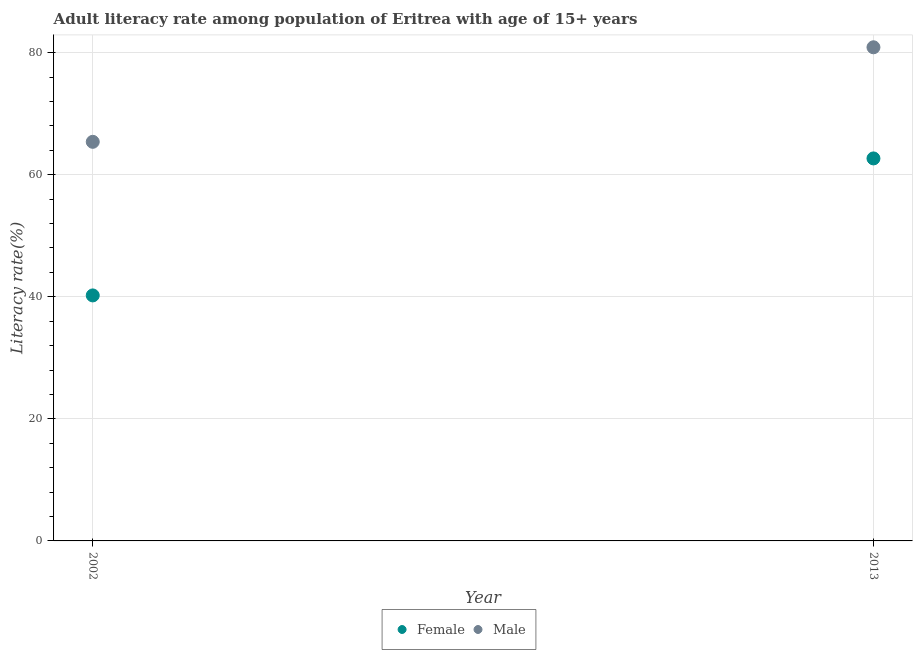How many different coloured dotlines are there?
Your answer should be very brief. 2. Is the number of dotlines equal to the number of legend labels?
Keep it short and to the point. Yes. What is the female adult literacy rate in 2013?
Give a very brief answer. 62.67. Across all years, what is the maximum male adult literacy rate?
Your response must be concise. 80.88. Across all years, what is the minimum female adult literacy rate?
Keep it short and to the point. 40.22. In which year was the male adult literacy rate maximum?
Provide a succinct answer. 2013. What is the total female adult literacy rate in the graph?
Your answer should be compact. 102.9. What is the difference between the female adult literacy rate in 2002 and that in 2013?
Offer a terse response. -22.45. What is the difference between the female adult literacy rate in 2013 and the male adult literacy rate in 2002?
Give a very brief answer. -2.72. What is the average male adult literacy rate per year?
Your answer should be very brief. 73.14. In the year 2002, what is the difference between the male adult literacy rate and female adult literacy rate?
Offer a terse response. 25.17. What is the ratio of the male adult literacy rate in 2002 to that in 2013?
Keep it short and to the point. 0.81. In how many years, is the female adult literacy rate greater than the average female adult literacy rate taken over all years?
Your answer should be compact. 1. Does the female adult literacy rate monotonically increase over the years?
Ensure brevity in your answer.  Yes. Is the female adult literacy rate strictly less than the male adult literacy rate over the years?
Your response must be concise. Yes. How many years are there in the graph?
Provide a short and direct response. 2. What is the difference between two consecutive major ticks on the Y-axis?
Ensure brevity in your answer.  20. Are the values on the major ticks of Y-axis written in scientific E-notation?
Ensure brevity in your answer.  No. Does the graph contain any zero values?
Ensure brevity in your answer.  No. Does the graph contain grids?
Ensure brevity in your answer.  Yes. Where does the legend appear in the graph?
Your answer should be very brief. Bottom center. What is the title of the graph?
Keep it short and to the point. Adult literacy rate among population of Eritrea with age of 15+ years. Does "Health Care" appear as one of the legend labels in the graph?
Your response must be concise. No. What is the label or title of the Y-axis?
Provide a succinct answer. Literacy rate(%). What is the Literacy rate(%) of Female in 2002?
Give a very brief answer. 40.22. What is the Literacy rate(%) of Male in 2002?
Your answer should be very brief. 65.39. What is the Literacy rate(%) in Female in 2013?
Provide a short and direct response. 62.67. What is the Literacy rate(%) of Male in 2013?
Provide a succinct answer. 80.88. Across all years, what is the maximum Literacy rate(%) in Female?
Offer a terse response. 62.67. Across all years, what is the maximum Literacy rate(%) of Male?
Keep it short and to the point. 80.88. Across all years, what is the minimum Literacy rate(%) of Female?
Keep it short and to the point. 40.22. Across all years, what is the minimum Literacy rate(%) in Male?
Offer a very short reply. 65.39. What is the total Literacy rate(%) in Female in the graph?
Make the answer very short. 102.9. What is the total Literacy rate(%) of Male in the graph?
Offer a terse response. 146.27. What is the difference between the Literacy rate(%) in Female in 2002 and that in 2013?
Give a very brief answer. -22.45. What is the difference between the Literacy rate(%) of Male in 2002 and that in 2013?
Your answer should be compact. -15.49. What is the difference between the Literacy rate(%) in Female in 2002 and the Literacy rate(%) in Male in 2013?
Ensure brevity in your answer.  -40.66. What is the average Literacy rate(%) in Female per year?
Ensure brevity in your answer.  51.45. What is the average Literacy rate(%) of Male per year?
Your response must be concise. 73.14. In the year 2002, what is the difference between the Literacy rate(%) of Female and Literacy rate(%) of Male?
Offer a terse response. -25.17. In the year 2013, what is the difference between the Literacy rate(%) of Female and Literacy rate(%) of Male?
Keep it short and to the point. -18.21. What is the ratio of the Literacy rate(%) in Female in 2002 to that in 2013?
Ensure brevity in your answer.  0.64. What is the ratio of the Literacy rate(%) in Male in 2002 to that in 2013?
Provide a succinct answer. 0.81. What is the difference between the highest and the second highest Literacy rate(%) of Female?
Offer a very short reply. 22.45. What is the difference between the highest and the second highest Literacy rate(%) in Male?
Make the answer very short. 15.49. What is the difference between the highest and the lowest Literacy rate(%) in Female?
Make the answer very short. 22.45. What is the difference between the highest and the lowest Literacy rate(%) in Male?
Provide a succinct answer. 15.49. 